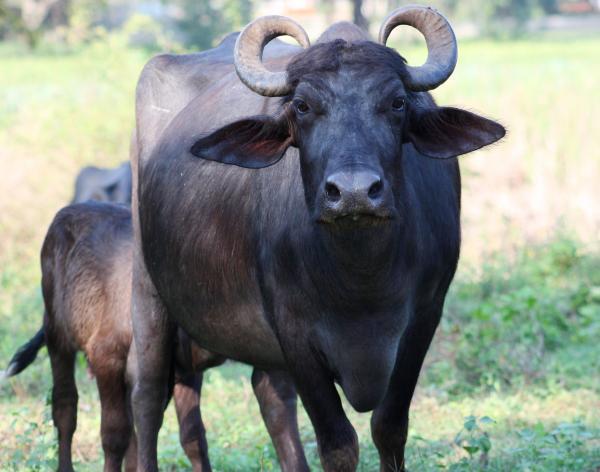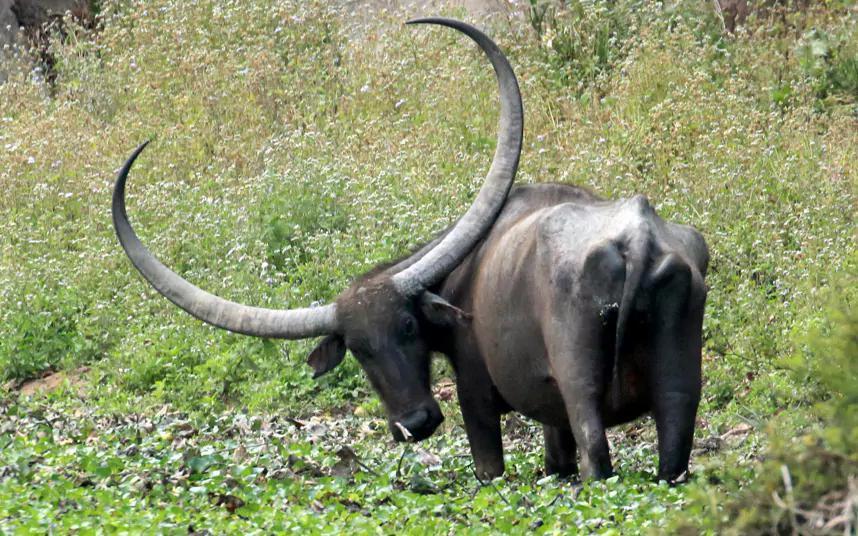The first image is the image on the left, the second image is the image on the right. Evaluate the accuracy of this statement regarding the images: "In the left image, one horned animal looks directly at the camera.". Is it true? Answer yes or no. Yes. The first image is the image on the left, the second image is the image on the right. Given the left and right images, does the statement "In one image, animals are standing in water beside a grassy area." hold true? Answer yes or no. No. 